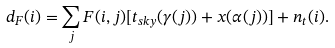Convert formula to latex. <formula><loc_0><loc_0><loc_500><loc_500>d _ { F } ( i ) = \sum _ { j } F ( i , j ) [ t _ { s k y } ( \gamma ( j ) ) + x ( \alpha ( j ) ) ] + n _ { t } ( i ) .</formula> 